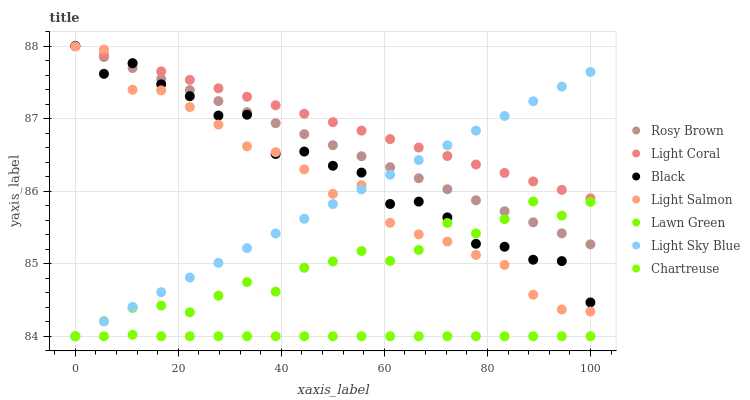Does Chartreuse have the minimum area under the curve?
Answer yes or no. Yes. Does Light Coral have the maximum area under the curve?
Answer yes or no. Yes. Does Light Salmon have the minimum area under the curve?
Answer yes or no. No. Does Light Salmon have the maximum area under the curve?
Answer yes or no. No. Is Light Sky Blue the smoothest?
Answer yes or no. Yes. Is Black the roughest?
Answer yes or no. Yes. Is Light Salmon the smoothest?
Answer yes or no. No. Is Light Salmon the roughest?
Answer yes or no. No. Does Lawn Green have the lowest value?
Answer yes or no. Yes. Does Light Salmon have the lowest value?
Answer yes or no. No. Does Black have the highest value?
Answer yes or no. Yes. Does Light Salmon have the highest value?
Answer yes or no. No. Is Lawn Green less than Light Coral?
Answer yes or no. Yes. Is Light Coral greater than Chartreuse?
Answer yes or no. Yes. Does Light Salmon intersect Light Sky Blue?
Answer yes or no. Yes. Is Light Salmon less than Light Sky Blue?
Answer yes or no. No. Is Light Salmon greater than Light Sky Blue?
Answer yes or no. No. Does Lawn Green intersect Light Coral?
Answer yes or no. No. 